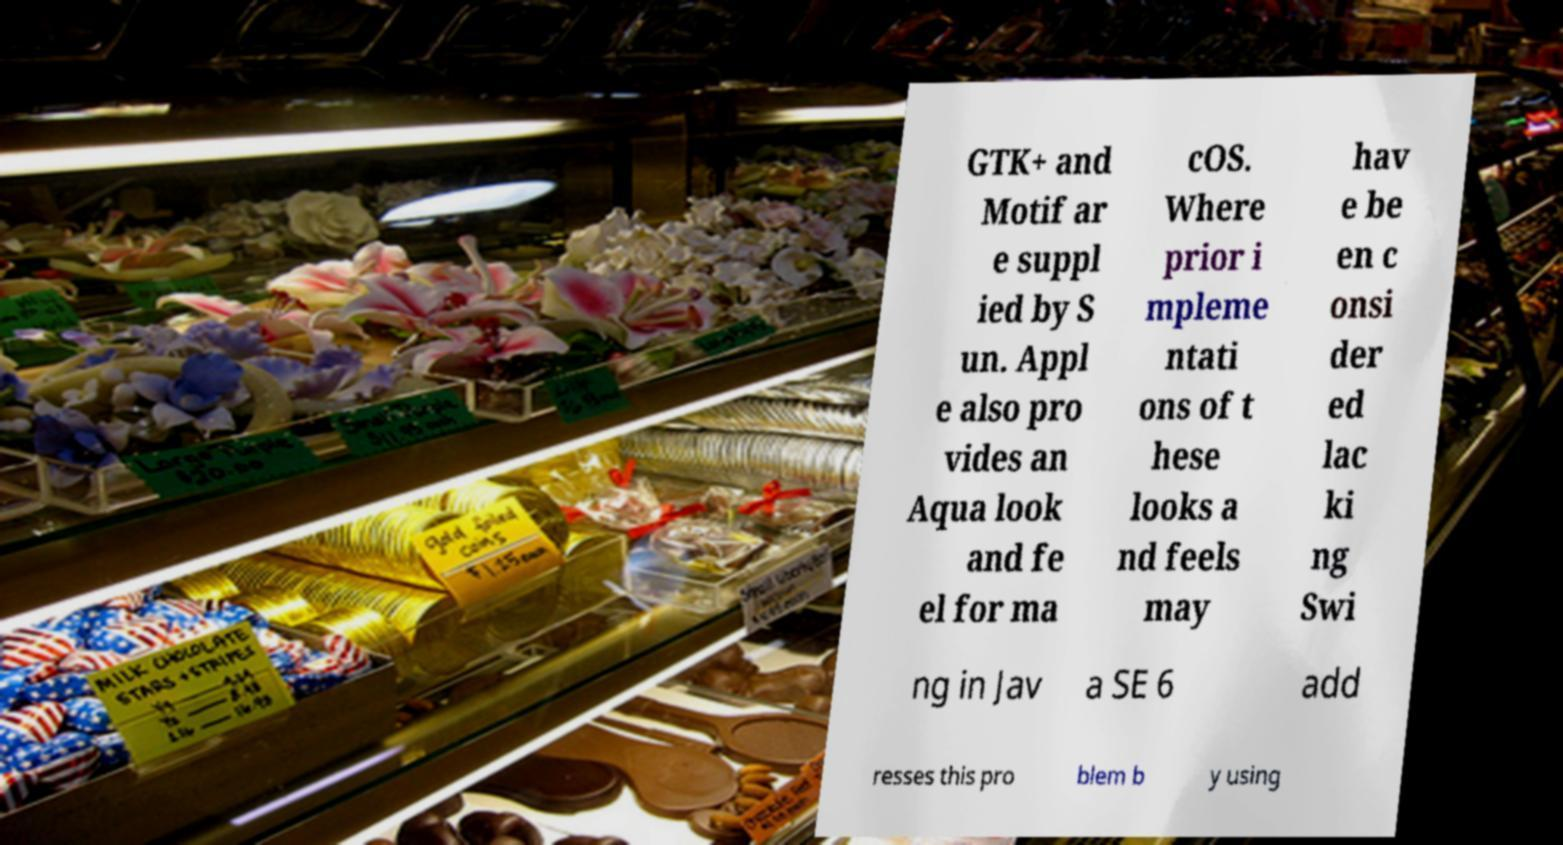Could you extract and type out the text from this image? GTK+ and Motif ar e suppl ied by S un. Appl e also pro vides an Aqua look and fe el for ma cOS. Where prior i mpleme ntati ons of t hese looks a nd feels may hav e be en c onsi der ed lac ki ng Swi ng in Jav a SE 6 add resses this pro blem b y using 